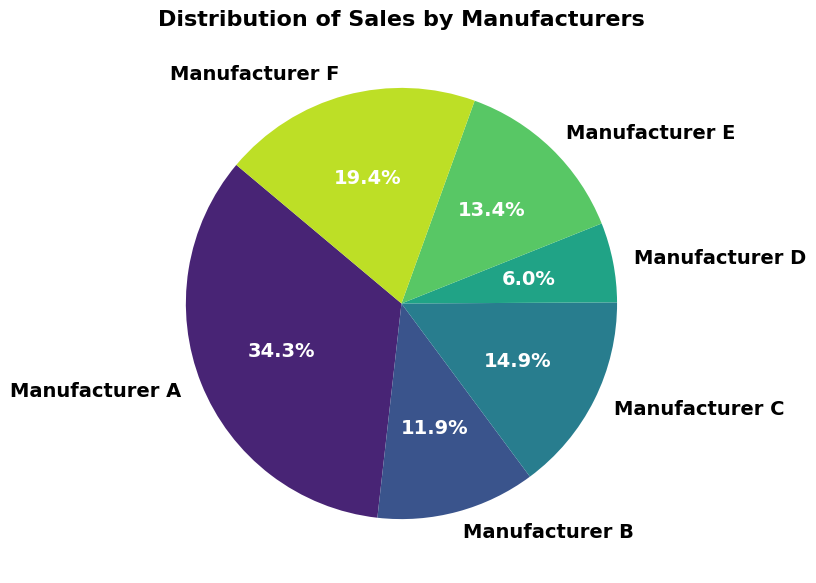What percentage of total sales is contributed by Manufacturer A? To find the percentage contribution of Manufacturer A to total sales, first sum Manufacturer A’s total sales (50000 + 20000 + 45000 = 115000). Then sum the total sales of all manufacturers in the pie chart. The percentage is (115000 / sum of all total sales) * 100.
Answer: 31.9% How do the total sales of Manufacturer B compare to Manufacturer F? Sum the total sales for Manufacturer B (30000 + 10000 = 40000) and Manufacturer F (35000 + 30000 = 65000). Manufacturer F has higher total sales than Manufacturer B.
Answer: Manufacturer F has higher total sales Which manufacturer has the smallest segment in the pie chart? Visually compare the segments in the pie chart. Manufacturer D should have the smallest segment as its total sales (15000 + 5000 = 20000) are the lowest.
Answer: Manufacturer D How is the sales distribution for manufacturers with a quality rating of 5? Identify manufacturers with a quality rating of 5 (Manufacturer A, Manufacturer C, Manufacturer E, Manufacturer F) and sum their sales (50000 + 40000 + 25000 + 30000 = 145000).
Answer: 145000 in total Which manufacturer has the largest segment in the pie chart? Visually identify the largest segment in the pie chart by comparing the sizes of the segments. Manufacturer A, with total sales of 115000, has the largest segment.
Answer: Manufacturer A What is the combined percentage share of Manufacturer C and Manufacturer E? Identify the total sales for Manufacturer C (40000 + 10000 = 50000) and Manufacturer E (25000 + 20000 = 45000). Sum these values (50000 + 45000 = 95000) and calculate the percentage share (95000 / sum of all total sales) * 100.
Answer: 26.4% How does the total sales of manufacturers with a quality rating of 4 compare to those with a quality rating of 3? Sum the total sales for quality rating 4 (Manufacturer B, Manufacturer D, Manufacturer A, Manufacturer E, Manufacturer F) and quality rating 3 (Manufacturer A, Manufacturer B, Manufacturer C, Manufacturer D). Compare these sums to determine which is higher.
Answer: Quality rating 4 is higher Which manufacturers have almost the same size segments in the distribution? Visually identify segments that appear to be similar in size in the pie chart. Manufacturer B and Manufacturer C should appear similar in size. Observe their respective total sales.
Answer: Manufacturer B and Manufacturer C How does the total sales distribution compare among manufacturers with the highest quality rating? Identify manufacturers with a quality rating of 5 (Manufacturer A, Manufacturer C, Manufacturer E, Manufacturer F) and compare their total sales visually in the pie chart.
Answer: Manufacturer A > Manufacturer C > Manufacturer F > Manufacturer E What proportion of the total sales does Manufacturer D contribute? Calculate the proportion of Manufacturer D's total sales (15000 + 5000 = 20000) compared to the total sales of all manufacturers and express it as a percentage.
Answer: 5.5% 